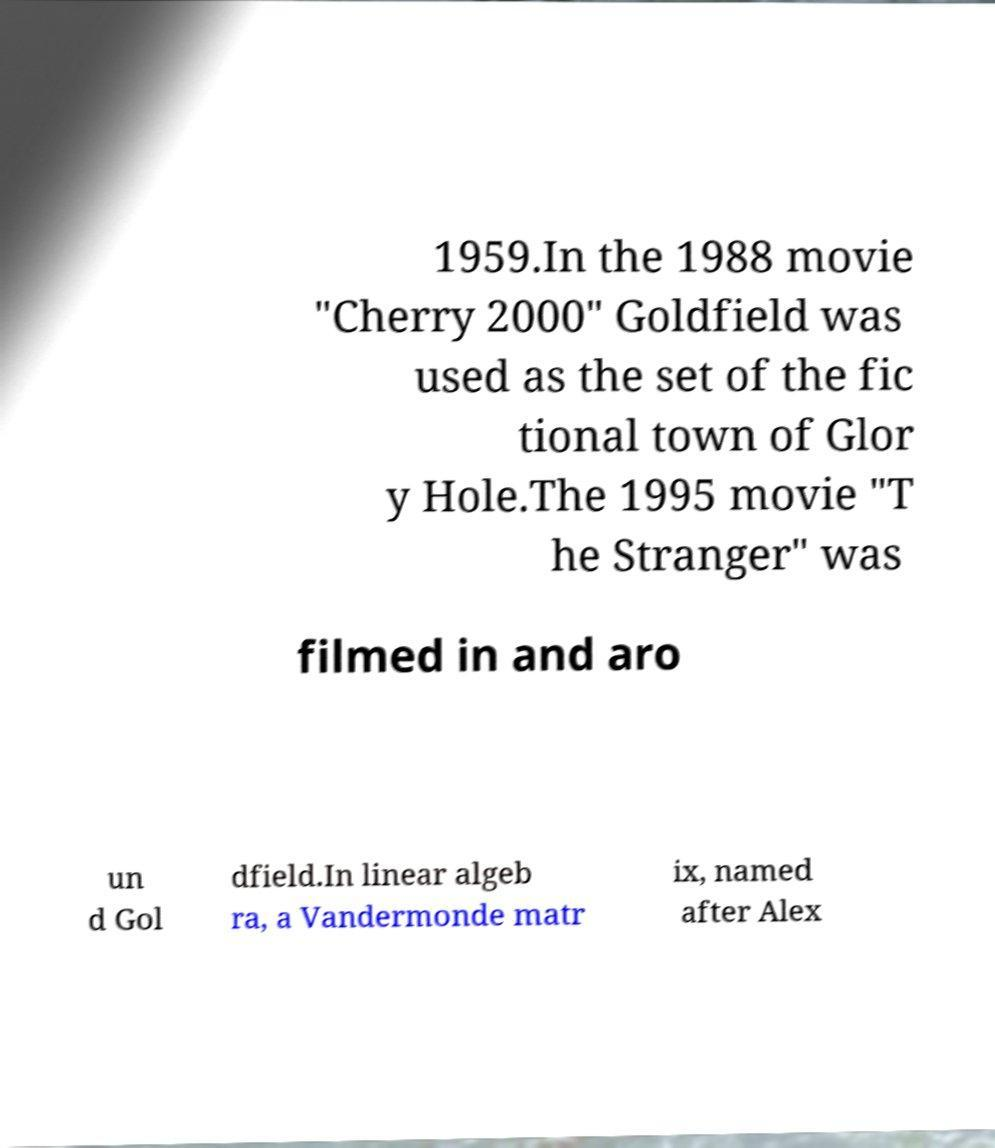Could you assist in decoding the text presented in this image and type it out clearly? 1959.In the 1988 movie "Cherry 2000" Goldfield was used as the set of the fic tional town of Glor y Hole.The 1995 movie "T he Stranger" was filmed in and aro un d Gol dfield.In linear algeb ra, a Vandermonde matr ix, named after Alex 